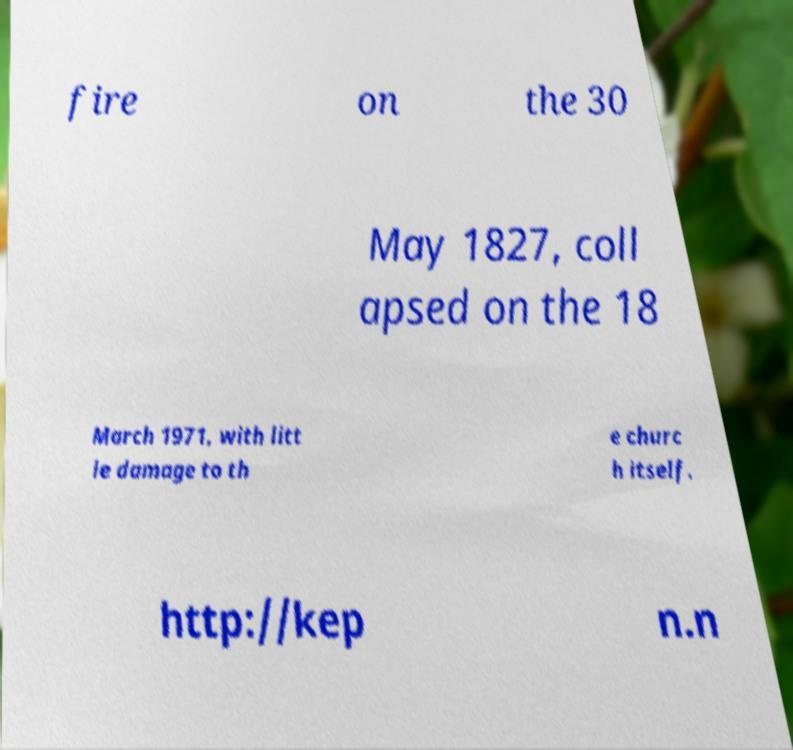Can you read and provide the text displayed in the image?This photo seems to have some interesting text. Can you extract and type it out for me? fire on the 30 May 1827, coll apsed on the 18 March 1971, with litt le damage to th e churc h itself. http://kep n.n 